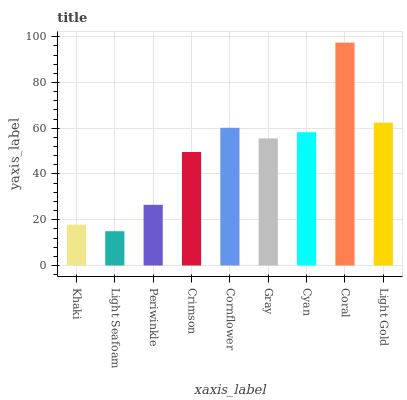Is Light Seafoam the minimum?
Answer yes or no. Yes. Is Coral the maximum?
Answer yes or no. Yes. Is Periwinkle the minimum?
Answer yes or no. No. Is Periwinkle the maximum?
Answer yes or no. No. Is Periwinkle greater than Light Seafoam?
Answer yes or no. Yes. Is Light Seafoam less than Periwinkle?
Answer yes or no. Yes. Is Light Seafoam greater than Periwinkle?
Answer yes or no. No. Is Periwinkle less than Light Seafoam?
Answer yes or no. No. Is Gray the high median?
Answer yes or no. Yes. Is Gray the low median?
Answer yes or no. Yes. Is Crimson the high median?
Answer yes or no. No. Is Cyan the low median?
Answer yes or no. No. 